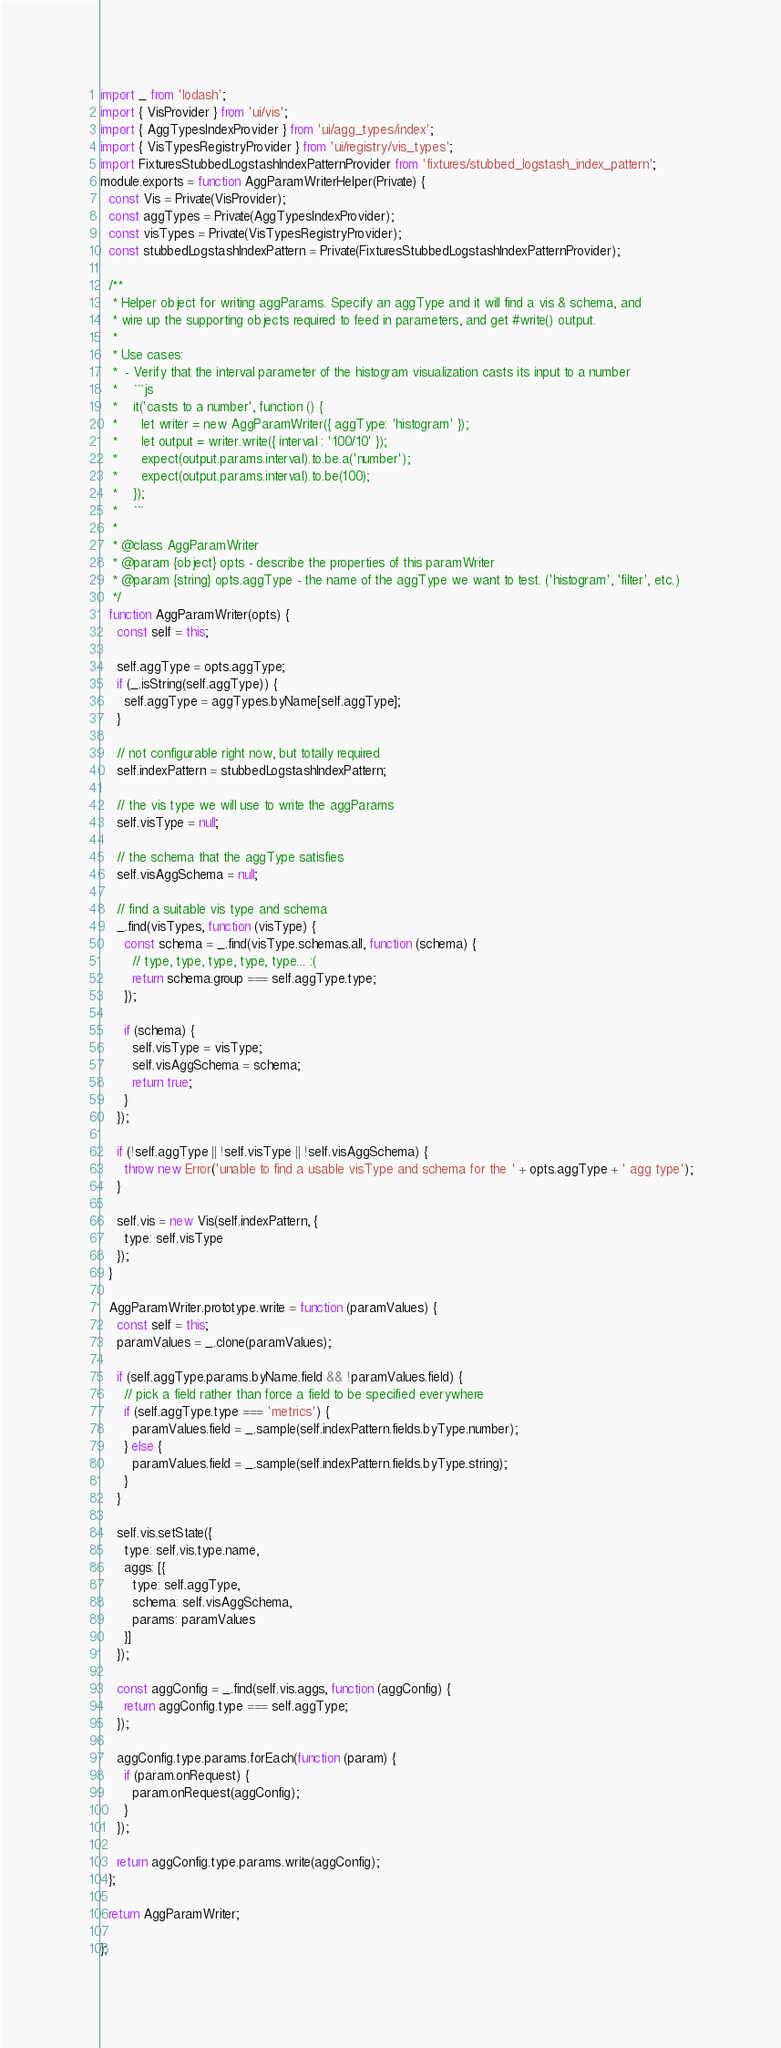<code> <loc_0><loc_0><loc_500><loc_500><_JavaScript_>import _ from 'lodash';
import { VisProvider } from 'ui/vis';
import { AggTypesIndexProvider } from 'ui/agg_types/index';
import { VisTypesRegistryProvider } from 'ui/registry/vis_types';
import FixturesStubbedLogstashIndexPatternProvider from 'fixtures/stubbed_logstash_index_pattern';
module.exports = function AggParamWriterHelper(Private) {
  const Vis = Private(VisProvider);
  const aggTypes = Private(AggTypesIndexProvider);
  const visTypes = Private(VisTypesRegistryProvider);
  const stubbedLogstashIndexPattern = Private(FixturesStubbedLogstashIndexPatternProvider);

  /**
   * Helper object for writing aggParams. Specify an aggType and it will find a vis & schema, and
   * wire up the supporting objects required to feed in parameters, and get #write() output.
   *
   * Use cases:
   *  - Verify that the interval parameter of the histogram visualization casts its input to a number
   *    ```js
   *    it('casts to a number', function () {
   *      let writer = new AggParamWriter({ aggType: 'histogram' });
   *      let output = writer.write({ interval : '100/10' });
   *      expect(output.params.interval).to.be.a('number');
   *      expect(output.params.interval).to.be(100);
   *    });
   *    ```
   *
   * @class AggParamWriter
   * @param {object} opts - describe the properties of this paramWriter
   * @param {string} opts.aggType - the name of the aggType we want to test. ('histogram', 'filter', etc.)
   */
  function AggParamWriter(opts) {
    const self = this;

    self.aggType = opts.aggType;
    if (_.isString(self.aggType)) {
      self.aggType = aggTypes.byName[self.aggType];
    }

    // not configurable right now, but totally required
    self.indexPattern = stubbedLogstashIndexPattern;

    // the vis type we will use to write the aggParams
    self.visType = null;

    // the schema that the aggType satisfies
    self.visAggSchema = null;

    // find a suitable vis type and schema
    _.find(visTypes, function (visType) {
      const schema = _.find(visType.schemas.all, function (schema) {
        // type, type, type, type, type... :(
        return schema.group === self.aggType.type;
      });

      if (schema) {
        self.visType = visType;
        self.visAggSchema = schema;
        return true;
      }
    });

    if (!self.aggType || !self.visType || !self.visAggSchema) {
      throw new Error('unable to find a usable visType and schema for the ' + opts.aggType + ' agg type');
    }

    self.vis = new Vis(self.indexPattern, {
      type: self.visType
    });
  }

  AggParamWriter.prototype.write = function (paramValues) {
    const self = this;
    paramValues = _.clone(paramValues);

    if (self.aggType.params.byName.field && !paramValues.field) {
      // pick a field rather than force a field to be specified everywhere
      if (self.aggType.type === 'metrics') {
        paramValues.field = _.sample(self.indexPattern.fields.byType.number);
      } else {
        paramValues.field = _.sample(self.indexPattern.fields.byType.string);
      }
    }

    self.vis.setState({
      type: self.vis.type.name,
      aggs: [{
        type: self.aggType,
        schema: self.visAggSchema,
        params: paramValues
      }]
    });

    const aggConfig = _.find(self.vis.aggs, function (aggConfig) {
      return aggConfig.type === self.aggType;
    });

    aggConfig.type.params.forEach(function (param) {
      if (param.onRequest) {
        param.onRequest(aggConfig);
      }
    });

    return aggConfig.type.params.write(aggConfig);
  };

  return AggParamWriter;

};
</code> 